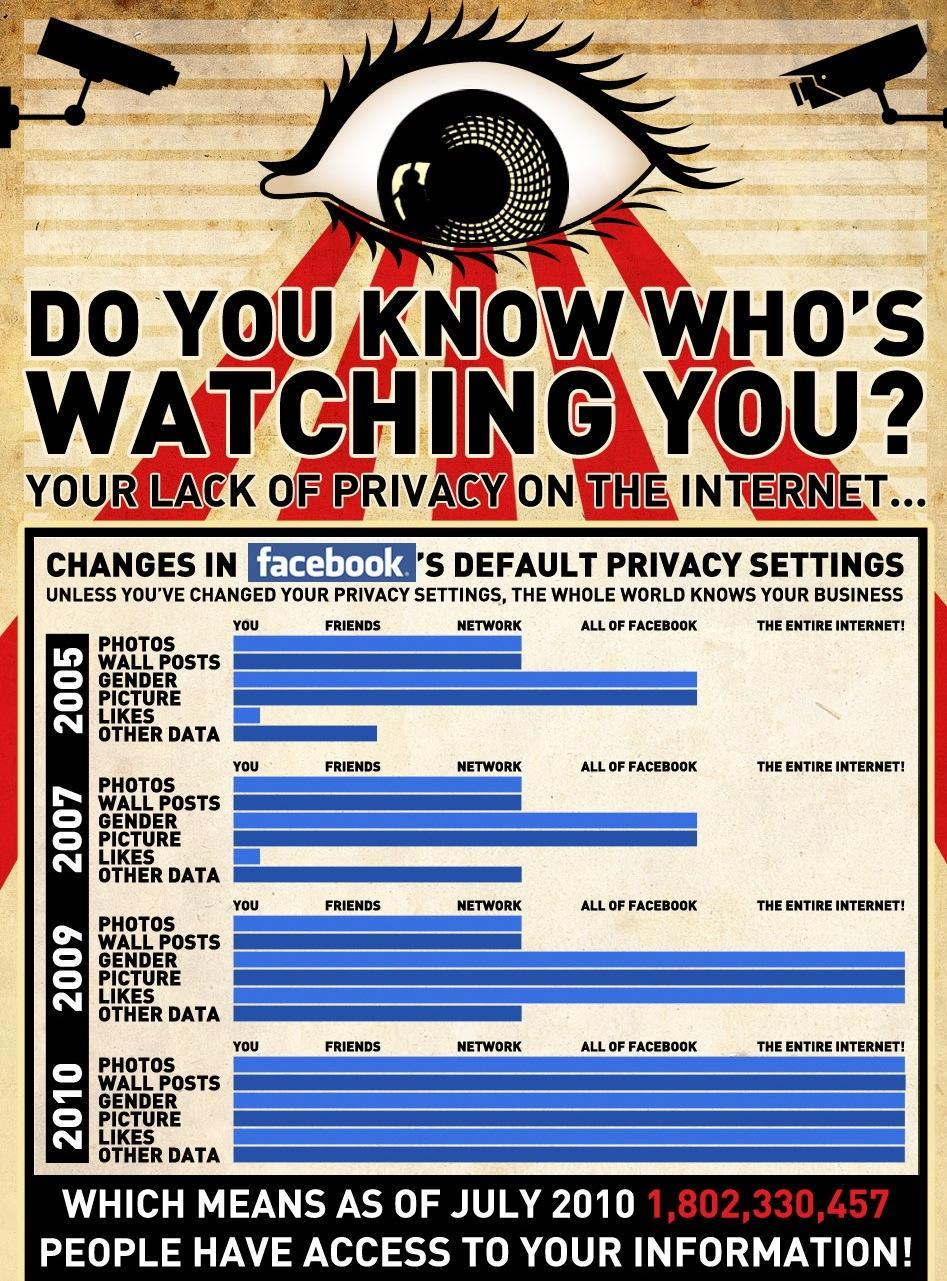What is the default privacy setting of Facebook features Gender and Picture in 2007?
Answer the question with a short phrase. All Of Facebook What is the default privacy setting of Facebook feature Other data in 2005? Friends Which feature of Facebook can be seen by anyone who have a Facebook account in the year 2005? Gender, Picture Which is the third level privacy setting of Facebook? Network By which year Other Data feature of Facebook was made open to the Network level? 2007 By which year all the Facebook features where made available on the entire internet? 2010 What was the change in the default privacy settings of the feature "Likes" from 2005 to 2009? The Entire Internet! Which features from Facebook were made open to the Network in 2009? Photos, Wall Posts, Other data What are the features of Facebook that can be seen by anyone who uses the internet in 2009? Gender, Picture, Likes Which is the second level privacy setting of Facebook? Friends 